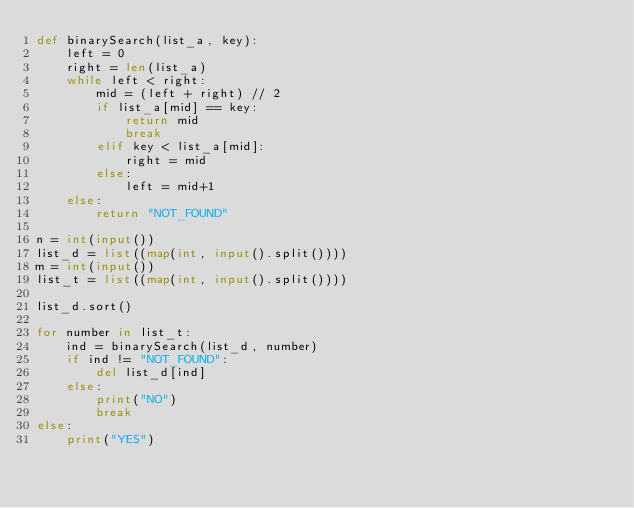<code> <loc_0><loc_0><loc_500><loc_500><_Python_>def binarySearch(list_a, key):
    left = 0
    right = len(list_a)
    while left < right:
        mid = (left + right) // 2
        if list_a[mid] == key:
            return mid
            break
        elif key < list_a[mid]:
            right = mid
        else:
            left = mid+1
    else:
        return "NOT_FOUND"

n = int(input())
list_d = list((map(int, input().split())))
m = int(input())
list_t = list((map(int, input().split())))

list_d.sort()

for number in list_t:
    ind = binarySearch(list_d, number)
    if ind != "NOT_FOUND":
        del list_d[ind]
    else:
        print("NO")
        break
else:
    print("YES")
</code> 